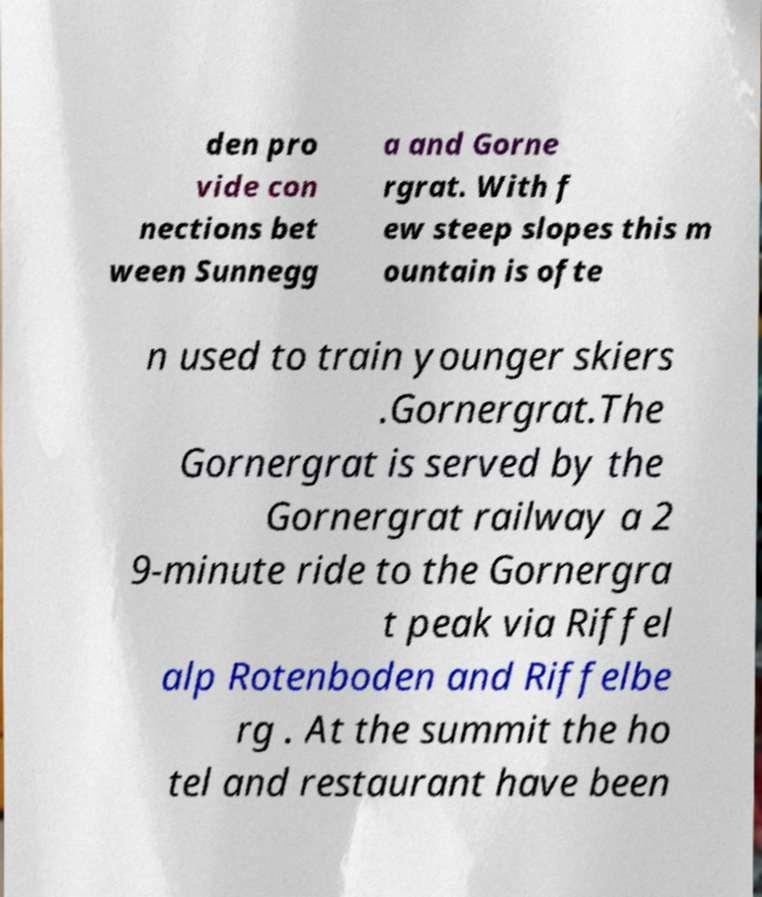Can you accurately transcribe the text from the provided image for me? den pro vide con nections bet ween Sunnegg a and Gorne rgrat. With f ew steep slopes this m ountain is ofte n used to train younger skiers .Gornergrat.The Gornergrat is served by the Gornergrat railway a 2 9-minute ride to the Gornergra t peak via Riffel alp Rotenboden and Riffelbe rg . At the summit the ho tel and restaurant have been 